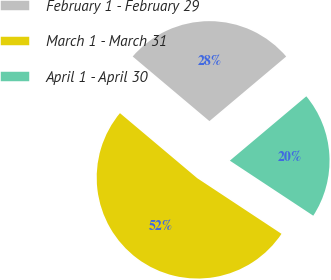<chart> <loc_0><loc_0><loc_500><loc_500><pie_chart><fcel>February 1 - February 29<fcel>March 1 - March 31<fcel>April 1 - April 30<nl><fcel>27.73%<fcel>51.85%<fcel>20.42%<nl></chart> 